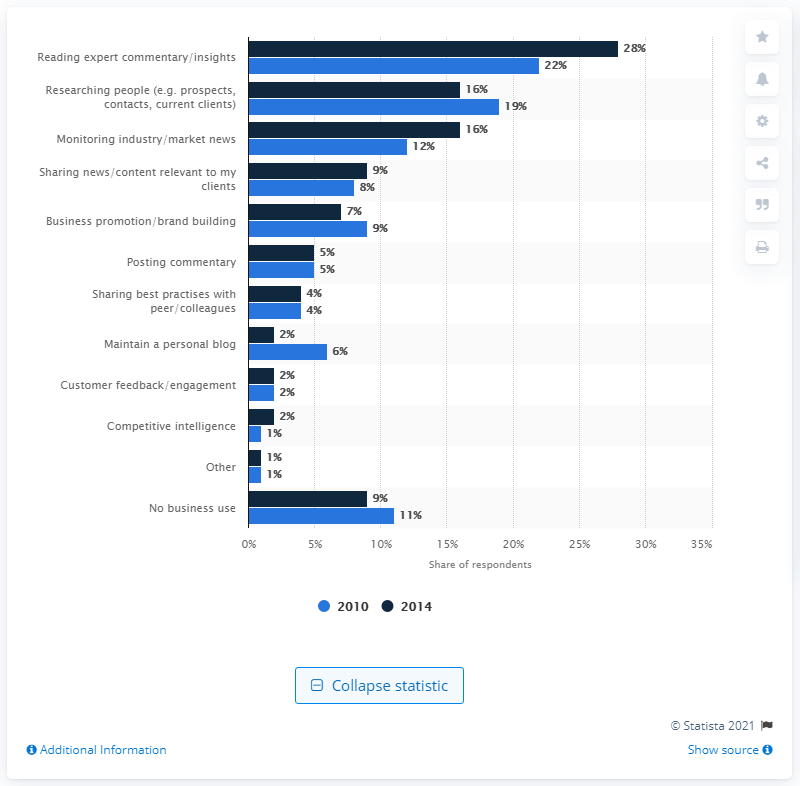List a handful of essential elements in this visual. According to the survey, 28% of respondents stated that reading expert commentary or insights was one of the most important business uses for social media. 